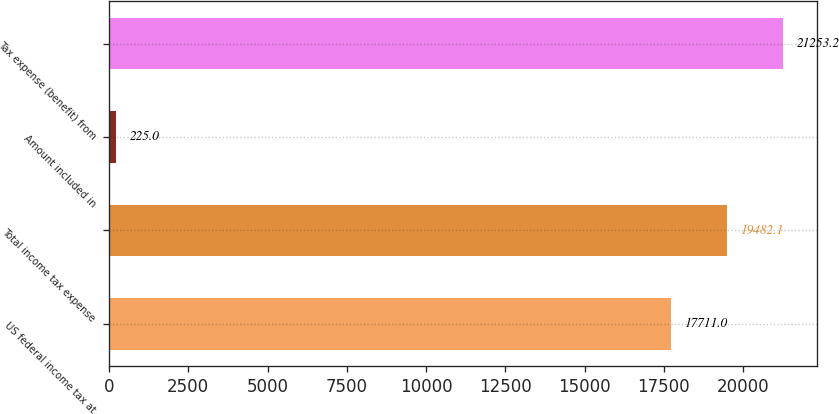Convert chart. <chart><loc_0><loc_0><loc_500><loc_500><bar_chart><fcel>US federal income tax at<fcel>Total income tax expense<fcel>Amount included in<fcel>Tax expense (benefit) from<nl><fcel>17711<fcel>19482.1<fcel>225<fcel>21253.2<nl></chart> 